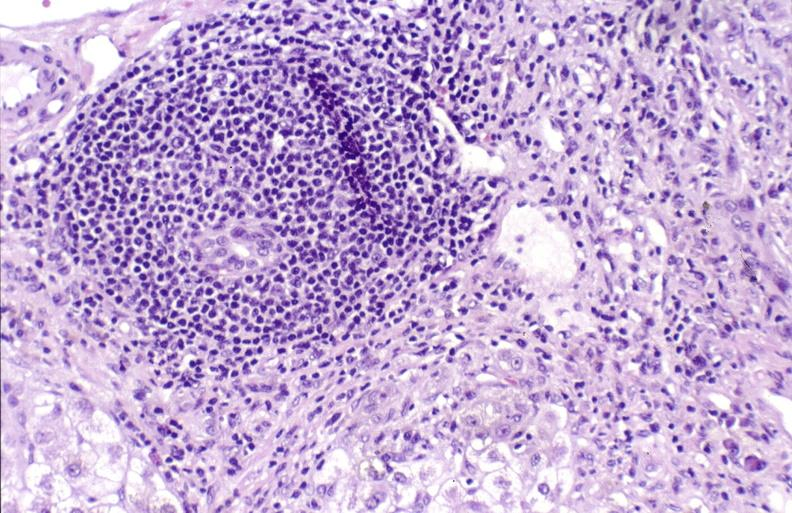does krukenberg tumor show primary biliary cirrhosis?
Answer the question using a single word or phrase. No 